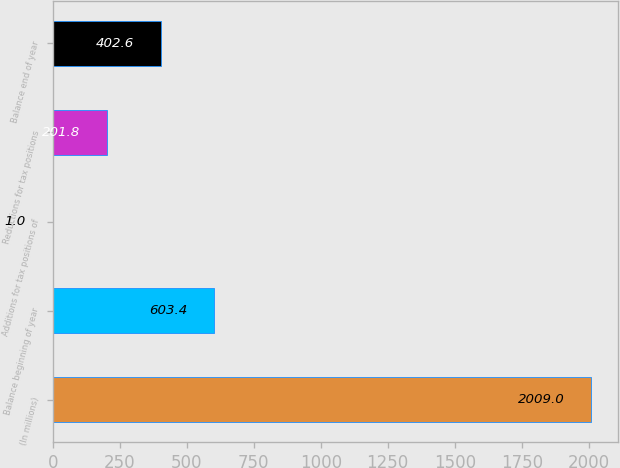<chart> <loc_0><loc_0><loc_500><loc_500><bar_chart><fcel>(In millions)<fcel>Balance beginning of year<fcel>Additions for tax positions of<fcel>Reductions for tax positions<fcel>Balance end of year<nl><fcel>2009<fcel>603.4<fcel>1<fcel>201.8<fcel>402.6<nl></chart> 